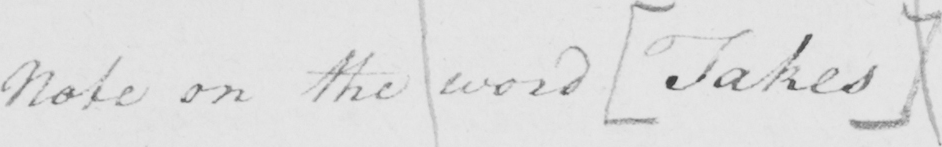What does this handwritten line say? Note on the word  [ Takes ] 